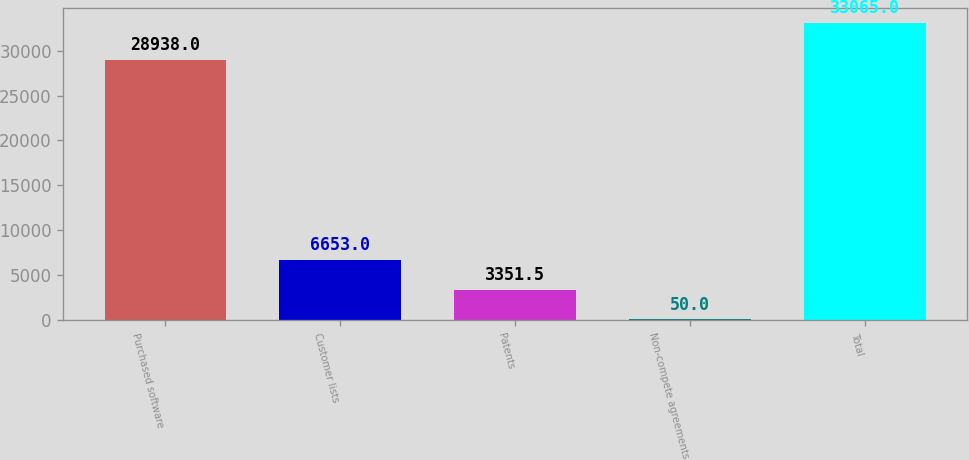Convert chart. <chart><loc_0><loc_0><loc_500><loc_500><bar_chart><fcel>Purchased software<fcel>Customer lists<fcel>Patents<fcel>Non-compete agreements<fcel>Total<nl><fcel>28938<fcel>6653<fcel>3351.5<fcel>50<fcel>33065<nl></chart> 